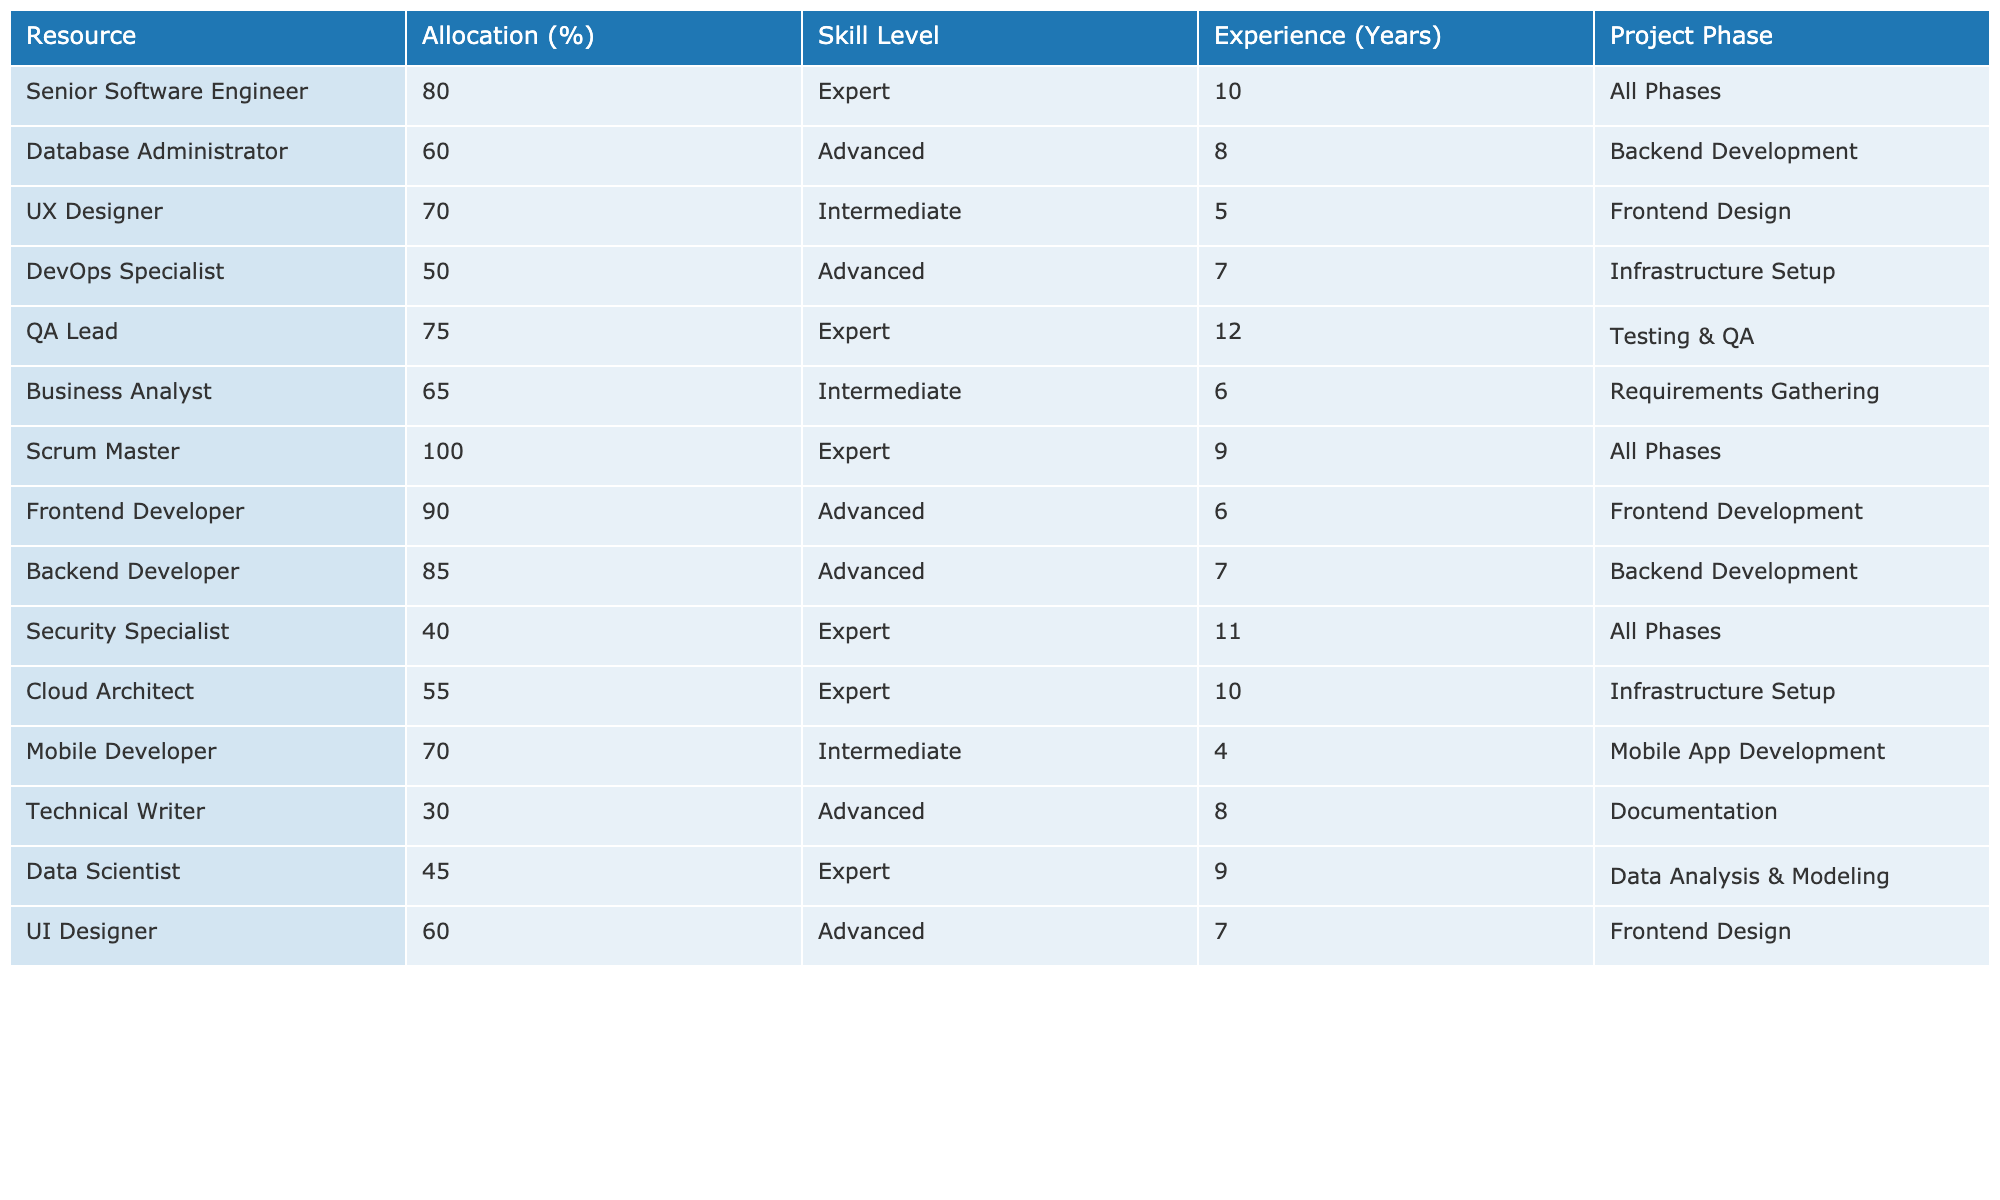What is the allocation percentage for the QA Lead? The allocation percentage for the QA Lead is found in the "Allocation (%)" column next to the resource "QA Lead". It is 75%.
Answer: 75% Which resource has the highest allocation percentage? The highest allocation percentage can be found by scanning the "Allocation (%)" column. "Scrum Master" has an allocation of 100%, which is the maximum.
Answer: 100% How many years of experience does the Database Administrator have? The number of years of experience for the Database Administrator is located in the "Experience (Years)" column next to the resource "Database Administrator". It shows 8 years.
Answer: 8 Is the Frontend Developer an expert in their skill level? By checking the "Skill Level" column next to the Frontend Developer, it is listed as "Advanced", which means they are not classified as an expert.
Answer: No What is the average allocation percentage of resources in the Backend Development phase? To find the average allocation percentage in the Backend Development phase, first, identify the relevant rows. The Database Administrator and Backend Developer both fall under this phase with allocations of 60% and 85%, respectively. The average is calculated by adding them (60 + 85 = 145) and dividing by 2 (145/2 = 72.5).
Answer: 72.5 Which resource has the least allocation percentage and how much is it? The least allocation percentage can be identified by looking at the "Allocation (%)" column. The Technical Writer has the least allocation at 30%.
Answer: 30 Are there any resources with a minimum experience of 10 years? Analyzing the "Experience (Years)" column shows that the Senior Software Engineer (10 years), Security Specialist (11 years), and QA Lead (12 years) exceed 10 years of experience. Therefore, the answer is yes.
Answer: Yes What is the skill level of the Security Specialist, and is it more than "Advanced"? The "Skill Level" for the Security Specialist is "Expert". Since "Expert" is higher than "Advanced", yes, it is more.
Answer: Yes How many resources have an intermediate skill level? To find the number of resources with an intermediate skill level, we review the "Skill Level" column. The resources with "Intermediate" skill level are UX Designer, Business Analyst, Mobile Developer, and UI Designer, which totals four resources.
Answer: 4 